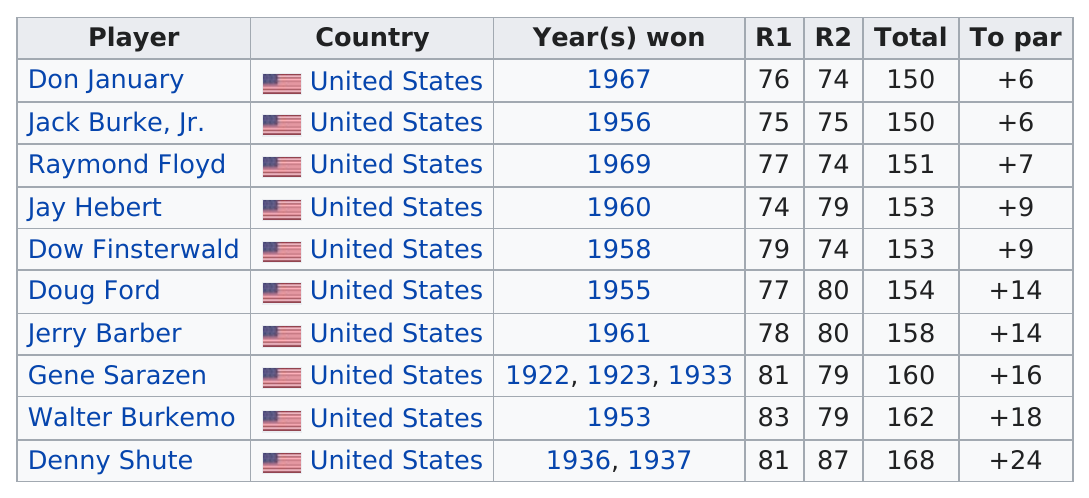Draw attention to some important aspects in this diagram. Gene Sarazen won the tournament three times. The total listed for the gene Sarazen is 160," said the clerk. Gene Sarazen, who has the most years won among players who missed the cut, is a notable golfer known for his impressive achievements in the sport. It has been 47 years since Don January won. Gene Sarazen, an American golfer, had the most wins, making him a prominent figure in the sport. 